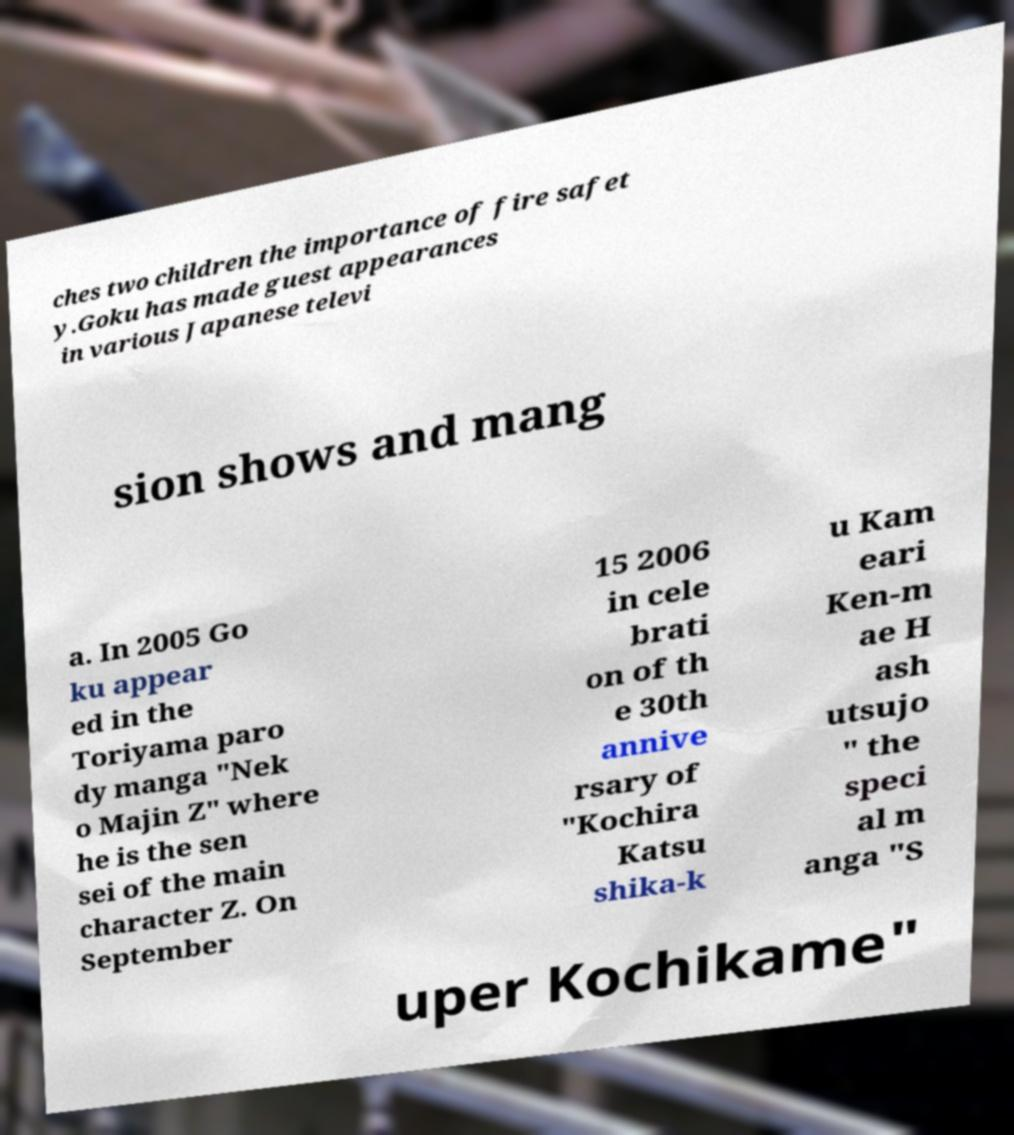I need the written content from this picture converted into text. Can you do that? ches two children the importance of fire safet y.Goku has made guest appearances in various Japanese televi sion shows and mang a. In 2005 Go ku appear ed in the Toriyama paro dy manga "Nek o Majin Z" where he is the sen sei of the main character Z. On September 15 2006 in cele brati on of th e 30th annive rsary of "Kochira Katsu shika-k u Kam eari Ken-m ae H ash utsujo " the speci al m anga "S uper Kochikame" 